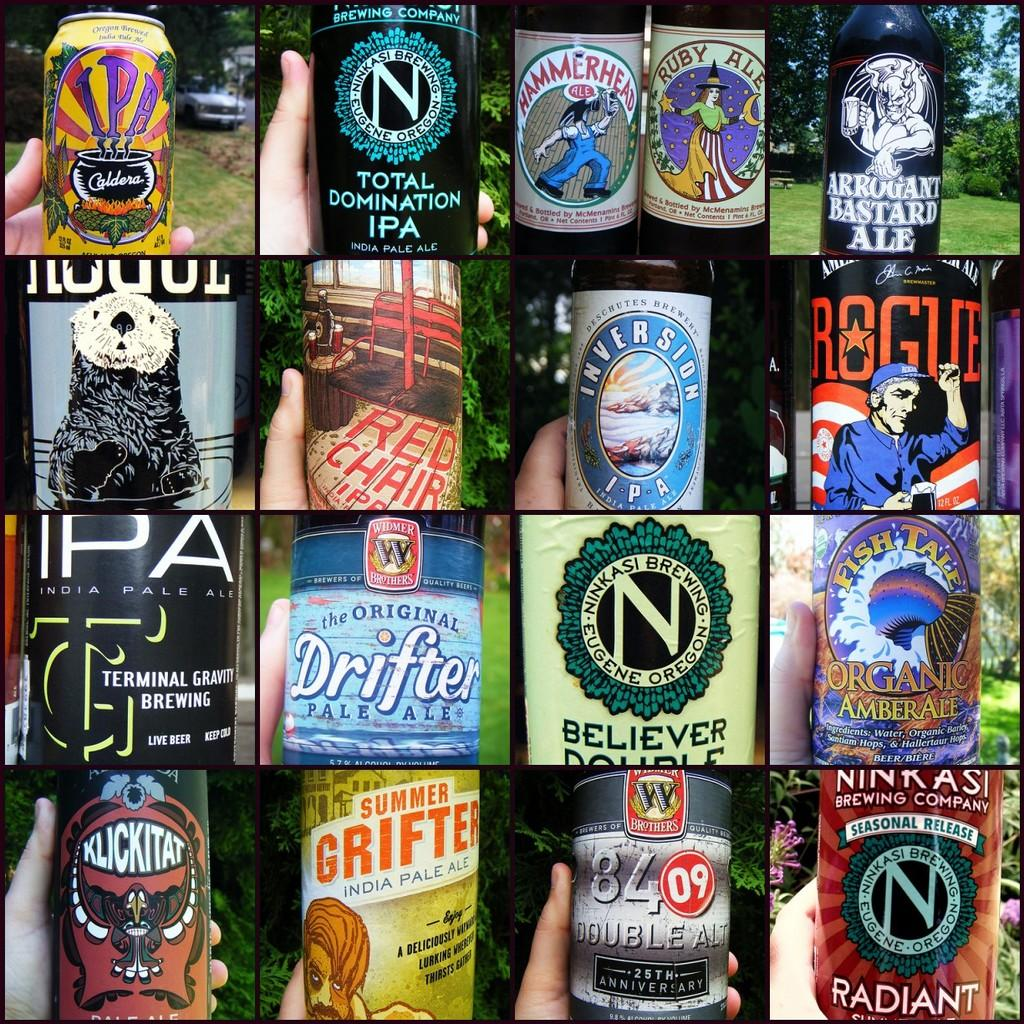What is the main theme of the image? The image is a collage of different pictures, each featuring a hand holding a bottle. What is consistent across all the pictures in the collage? In each picture, there is a hand holding a bottle. How do the bottles differ in the collage? Each picture has different bottles. What can be seen in the background of each picture? There are trees in the background of each picture. What type of shirt is the person wearing in the image? There is no person visible in the image, only hands holding bottles. Can you describe the field where the person is standing in the image? There is no field present in the image; it is a collage of pictures featuring hands holding bottles with trees in the background. 